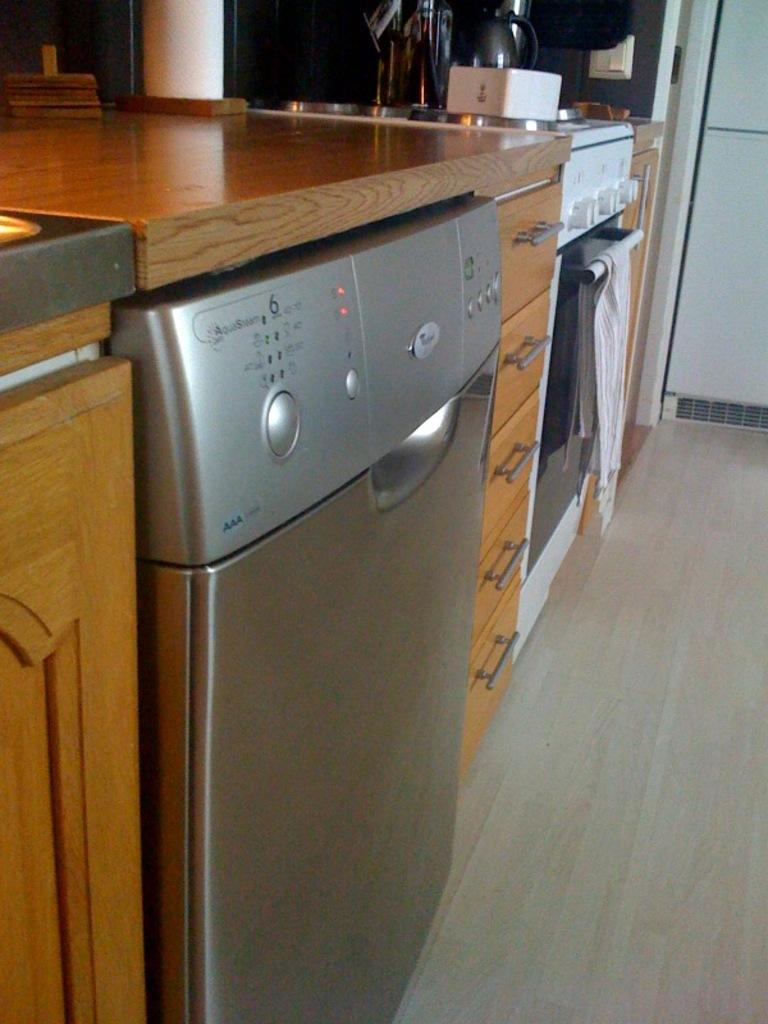What type of table is visible in the image? There is a wooden table in the image. What appliance is located under the table? There is a refrigerator under the table. What type of storage is available under the table? There are cupboards and storage racks under the table. What cooking appliances are present under the table? There is an oven, a stove, and a toaster under the table. Is there a woman standing next to the table in the image? There is no woman present in the image; it only shows a wooden table with appliances and storage options underneath. 